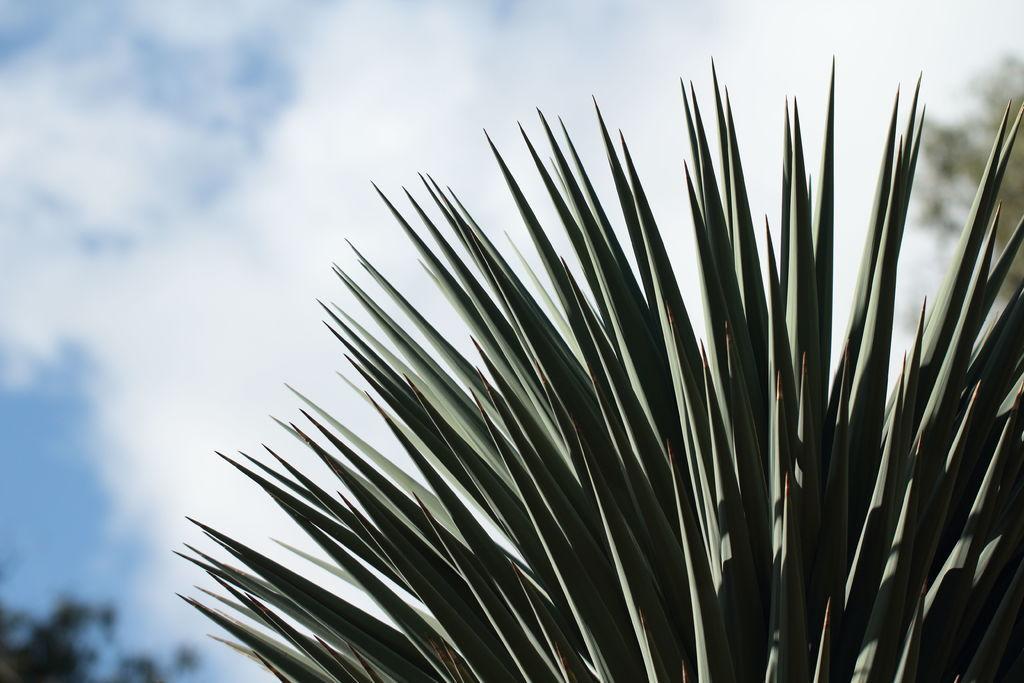In one or two sentences, can you explain what this image depicts? In this picture we can see few trees and clouds. 